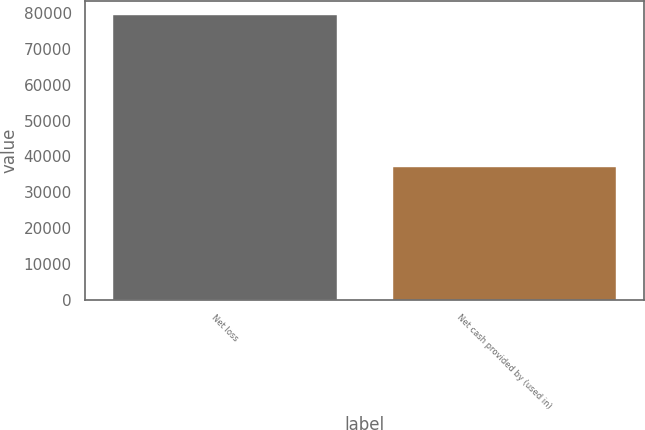<chart> <loc_0><loc_0><loc_500><loc_500><bar_chart><fcel>Net loss<fcel>Net cash provided by (used in)<nl><fcel>79399<fcel>37124<nl></chart> 